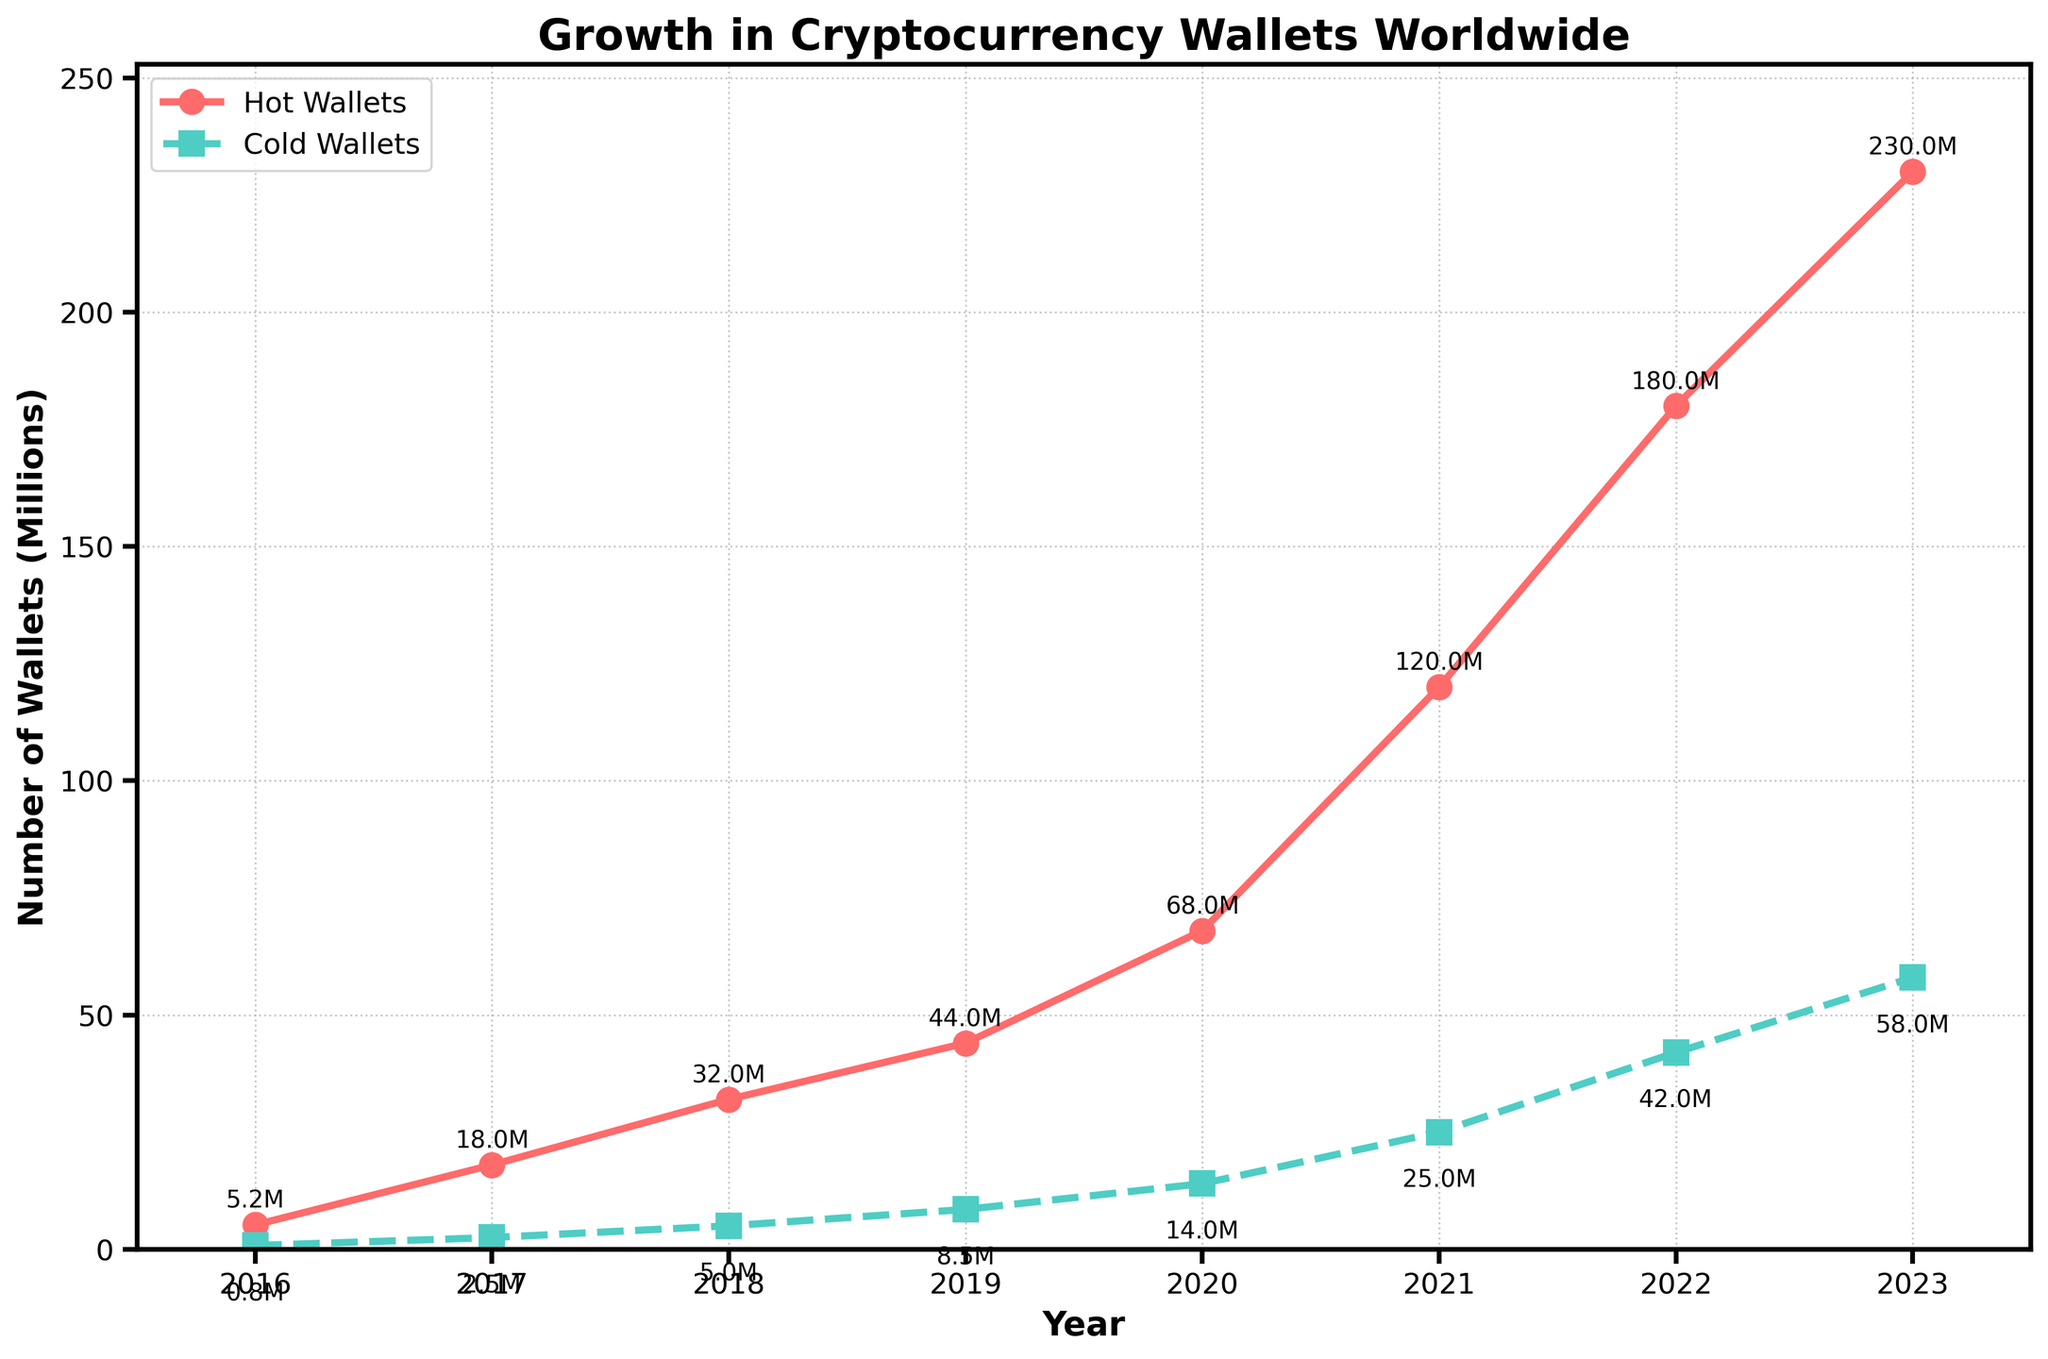Which year saw the biggest jump in the number of hot wallets? Look at the steepness of the lines representing hot wallets, find the period with the steepest line. Between 2020 and 2021, the hot wallets increased from 68 million to 120 million. So, the biggest jump is from 2020 to 2021.
Answer: 2021 What's the total number of cryptocurrency wallets (hot and cold) in 2020? Add the values of hot wallets and cold wallets for the year 2020: 68 million (hot) + 14 million (cold) = 82 million.
Answer: 82 million Which type of wallet had a greater percentage growth from 2016 to 2023? Calculate the percentage growth for both wallet types. For hot wallets: ((230 - 5.2) / 5.2) * 100 = approximately 4323%. For cold wallets: ((58 - 0.8) / 0.8) * 100 = approximately 7150%. Cold wallets had a greater percentage growth.
Answer: Cold Wallets How many million hot wallets were there in 2019? Check the graph for the value corresponding to the year 2019 for hot wallets. The value is 44 million.
Answer: 44 million By the end of 2023, how many more hot wallets than cold wallets were there? Subtract the number of cold wallets from the number of hot wallets in 2023: 230 million (hot) - 58 million (cold) = 172 million.
Answer: 172 million What is the average annual growth of cold wallets from 2016 to 2023? Calculate the annual growth by taking the difference from start to end, and dividing by the number of years minus one. (58 million - 0.8 million) / (2023 - 2016) = approximately 8.2 million per year.
Answer: 8.2 million Are there any years when the number of hot wallets did not increase from the previous year? Inspect the graph for any downward or flat segments in the hot wallets line. There are no years where the number of hot wallets decreased or stayed the same; it always increased.
Answer: No In which year did cold wallets exceed 10 million? Examine the graph to find the first year where cold wallets exceed 10 million. In 2020, cold wallets reached 14 million, thus the first year they exceeded 10 million was 2020.
Answer: 2020 What is the growth rate difference between hot and cold wallets from 2022 to 2023? Calculate the growth for each type and then find the difference. Hot wallets: (230 - 180) = 50 million. Cold wallets: (58 - 42) = 16 million. Difference: 50 million - 16 million = 34 million.
Answer: 34 million Between 2016 and 2023, which type of wallet saw the most consistent growth year over year? Analyze the graph to see which line is smoother with fewer fluctuations. The cold wallets line shows consistent growth, while the hot wallets line has steeper changes.
Answer: Cold Wallets 